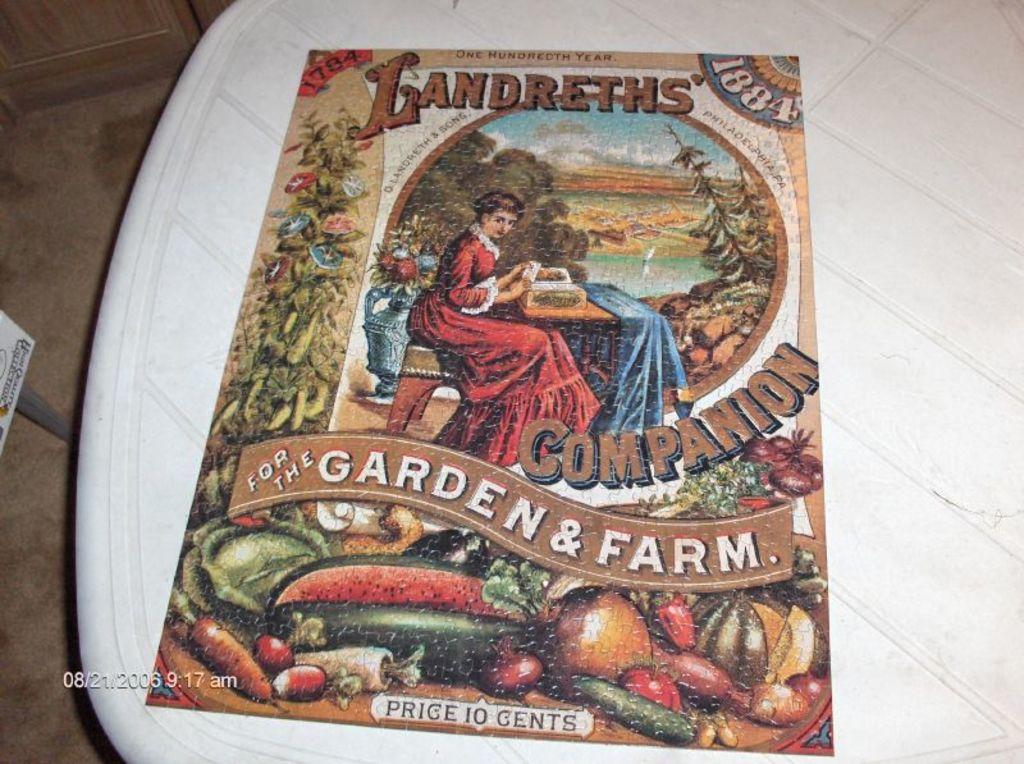What is the title of the publication?
Provide a succinct answer. Landreths' companion. What color is the table underneath the jigsaw puzzle?
Provide a succinct answer. Answering does not require reading text in the image. 